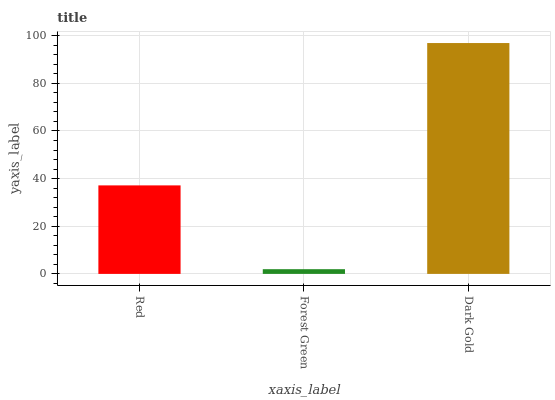Is Forest Green the minimum?
Answer yes or no. Yes. Is Dark Gold the maximum?
Answer yes or no. Yes. Is Dark Gold the minimum?
Answer yes or no. No. Is Forest Green the maximum?
Answer yes or no. No. Is Dark Gold greater than Forest Green?
Answer yes or no. Yes. Is Forest Green less than Dark Gold?
Answer yes or no. Yes. Is Forest Green greater than Dark Gold?
Answer yes or no. No. Is Dark Gold less than Forest Green?
Answer yes or no. No. Is Red the high median?
Answer yes or no. Yes. Is Red the low median?
Answer yes or no. Yes. Is Forest Green the high median?
Answer yes or no. No. Is Forest Green the low median?
Answer yes or no. No. 